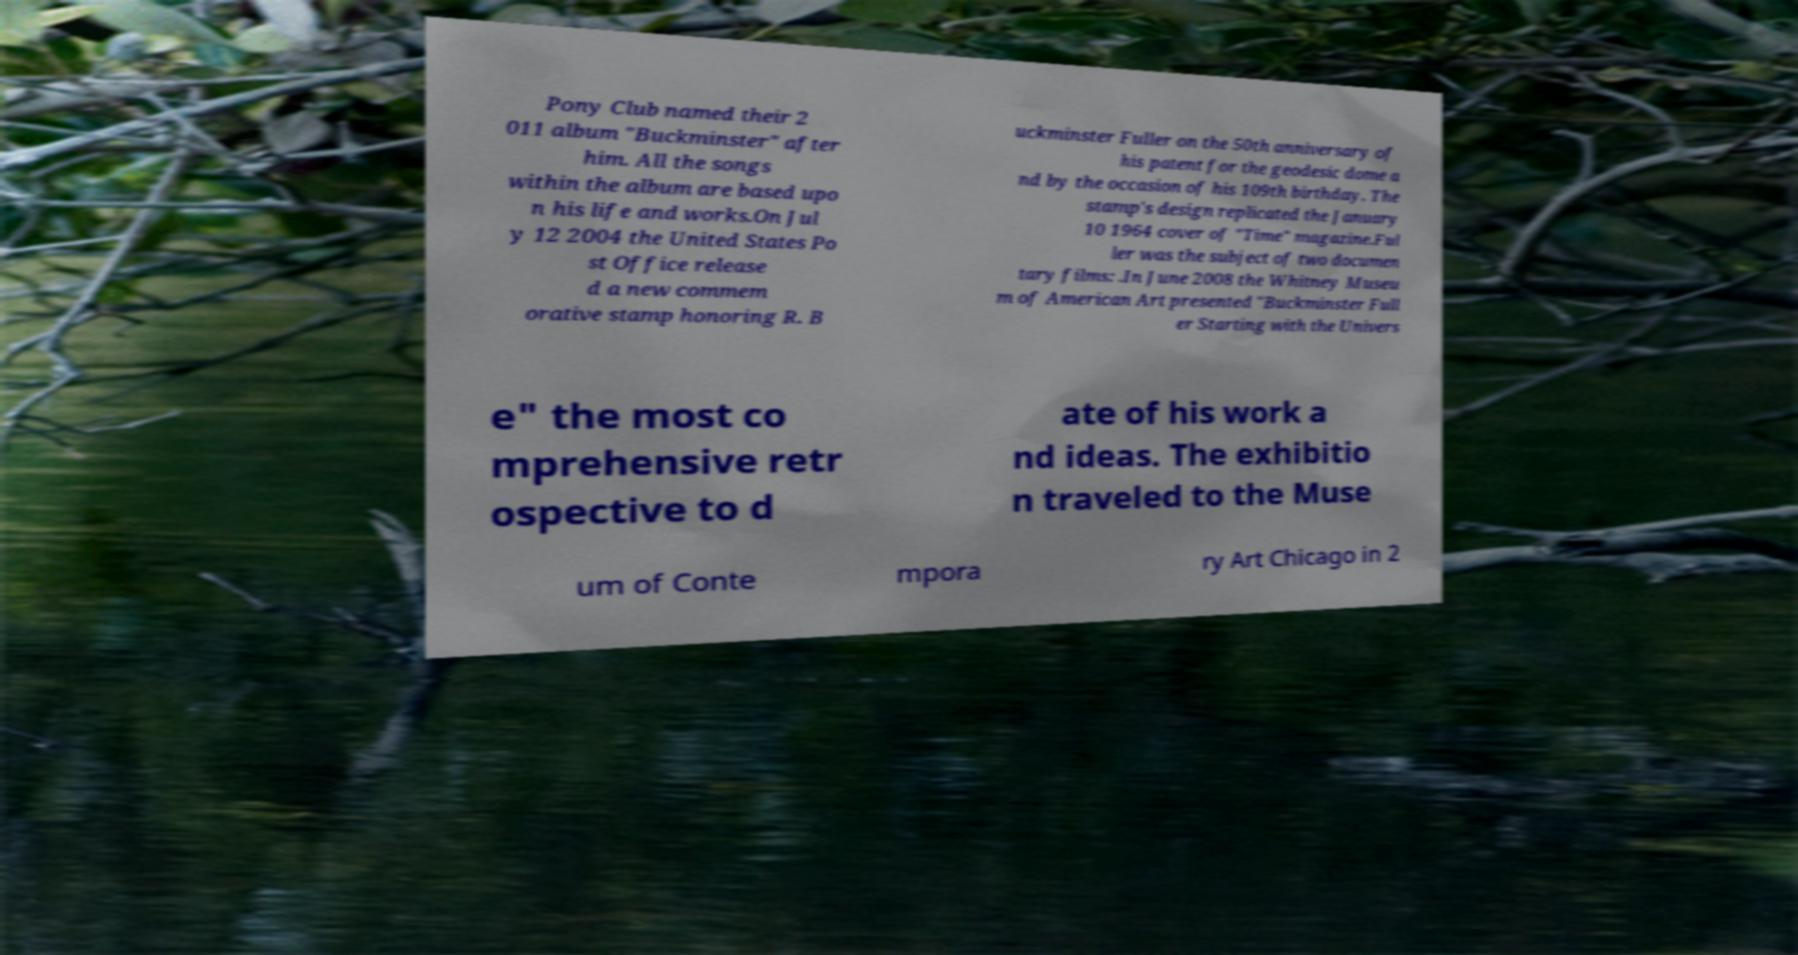For documentation purposes, I need the text within this image transcribed. Could you provide that? Pony Club named their 2 011 album "Buckminster" after him. All the songs within the album are based upo n his life and works.On Jul y 12 2004 the United States Po st Office release d a new commem orative stamp honoring R. B uckminster Fuller on the 50th anniversary of his patent for the geodesic dome a nd by the occasion of his 109th birthday. The stamp's design replicated the January 10 1964 cover of "Time" magazine.Ful ler was the subject of two documen tary films: .In June 2008 the Whitney Museu m of American Art presented "Buckminster Full er Starting with the Univers e" the most co mprehensive retr ospective to d ate of his work a nd ideas. The exhibitio n traveled to the Muse um of Conte mpora ry Art Chicago in 2 